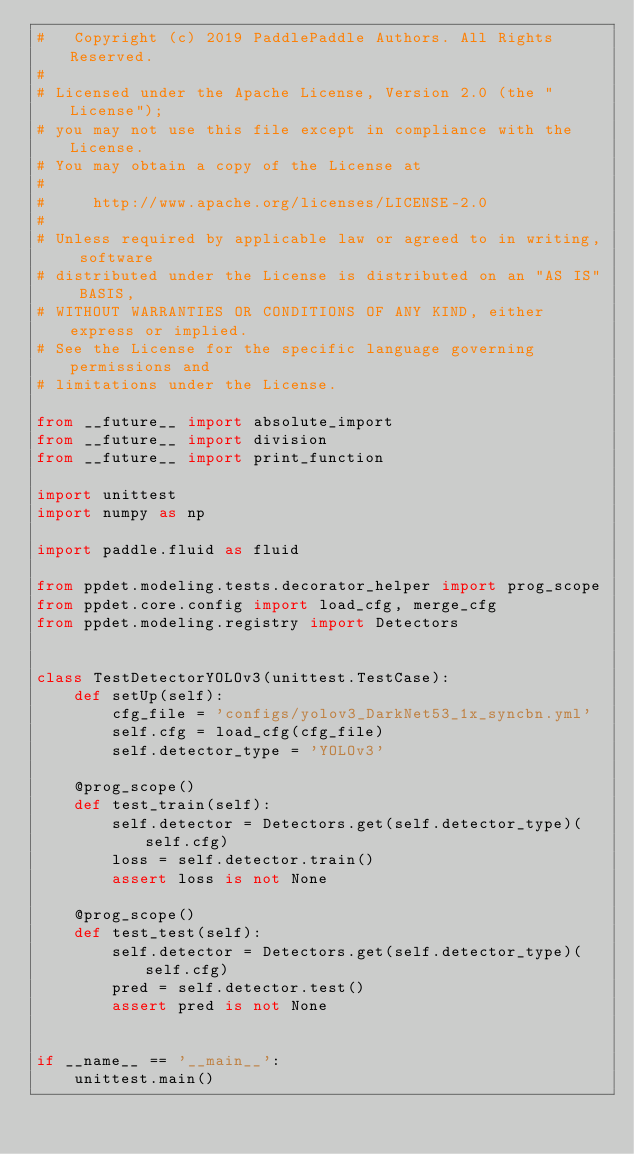<code> <loc_0><loc_0><loc_500><loc_500><_Python_>#   Copyright (c) 2019 PaddlePaddle Authors. All Rights Reserved.
#
# Licensed under the Apache License, Version 2.0 (the "License");
# you may not use this file except in compliance with the License.
# You may obtain a copy of the License at
#
#     http://www.apache.org/licenses/LICENSE-2.0
#
# Unless required by applicable law or agreed to in writing, software
# distributed under the License is distributed on an "AS IS" BASIS,
# WITHOUT WARRANTIES OR CONDITIONS OF ANY KIND, either express or implied.
# See the License for the specific language governing permissions and
# limitations under the License.

from __future__ import absolute_import
from __future__ import division
from __future__ import print_function

import unittest
import numpy as np

import paddle.fluid as fluid

from ppdet.modeling.tests.decorator_helper import prog_scope
from ppdet.core.config import load_cfg, merge_cfg
from ppdet.modeling.registry import Detectors


class TestDetectorYOLOv3(unittest.TestCase):
    def setUp(self):
        cfg_file = 'configs/yolov3_DarkNet53_1x_syncbn.yml'
        self.cfg = load_cfg(cfg_file)
        self.detector_type = 'YOLOv3'

    @prog_scope()
    def test_train(self):
        self.detector = Detectors.get(self.detector_type)(self.cfg)
        loss = self.detector.train()
        assert loss is not None

    @prog_scope()
    def test_test(self):
        self.detector = Detectors.get(self.detector_type)(self.cfg)
        pred = self.detector.test()
        assert pred is not None


if __name__ == '__main__':
    unittest.main()
</code> 